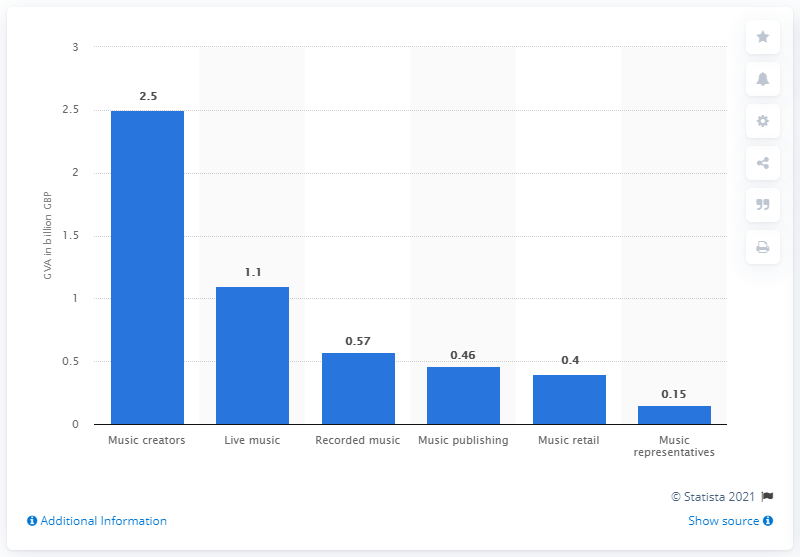Point out several critical features in this image. In 2018, the amount of GVA contributed by music creators was 2.5%. 